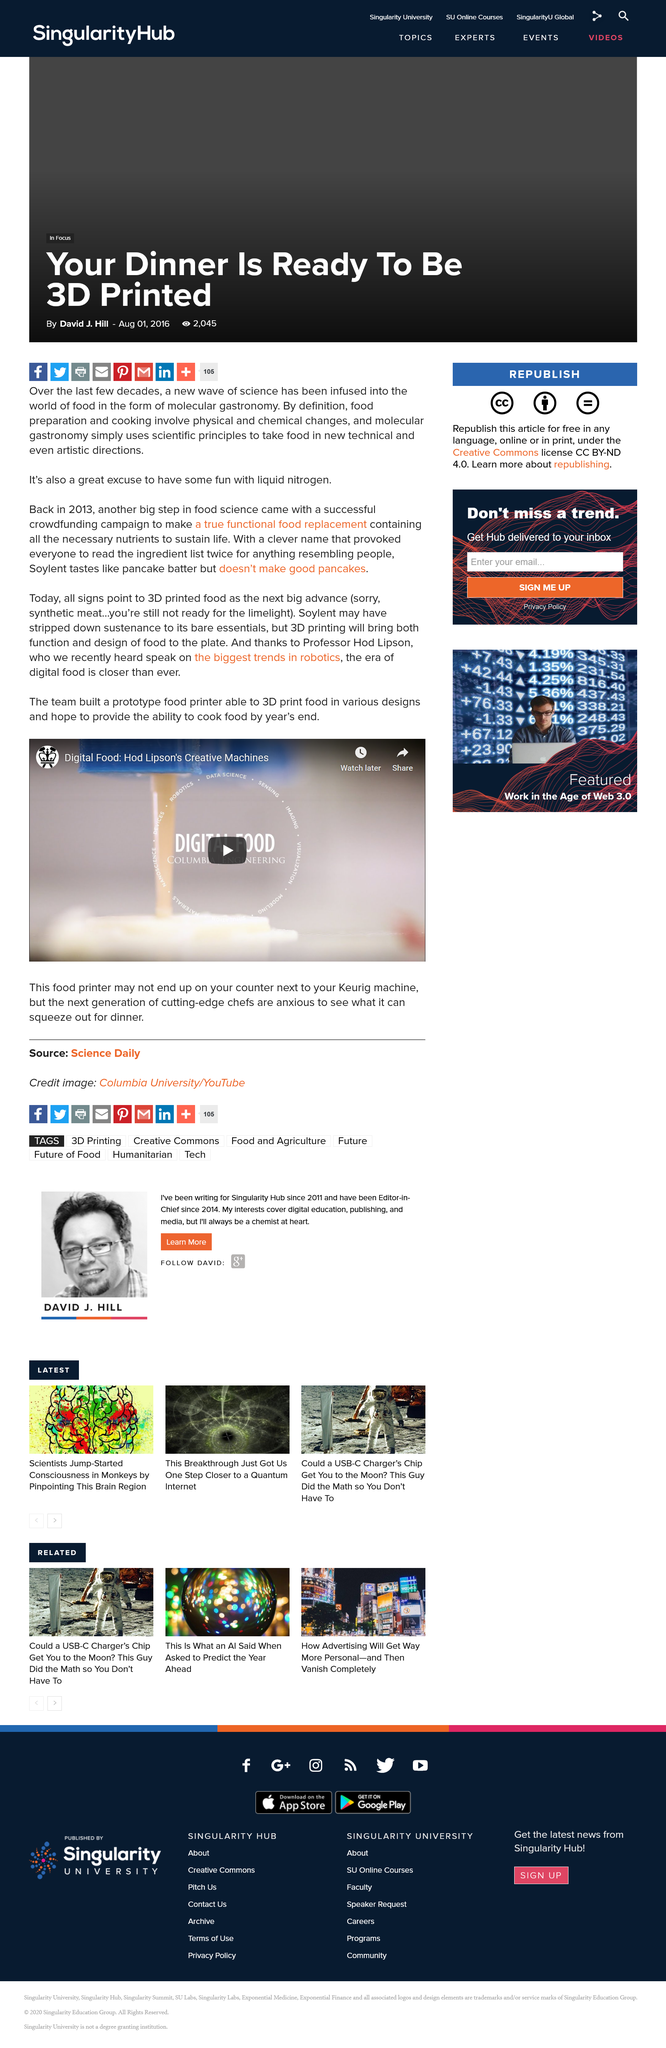Draw attention to some important aspects in this diagram. Our team has successfully built a 3D printer capable of printing food in a variety of designs. We hope to provide the ability to cook the printed food by the end of the year. The prototype food printer is a testament to our team's dedication to innovation and the potential of 3D printing technology in the culinary industry. 3D printed food represents a significant advancement in the field of food production and presents a promising future for the industry. 3D printing technology has revolutionized the way we think about and create food, bringing together both function and design to the plate in a way that was previously impossible. This innovative technology allows for the precise control of ingredients, creating complex shapes and textures that are not only visually appealing but also functional and nutritious. 